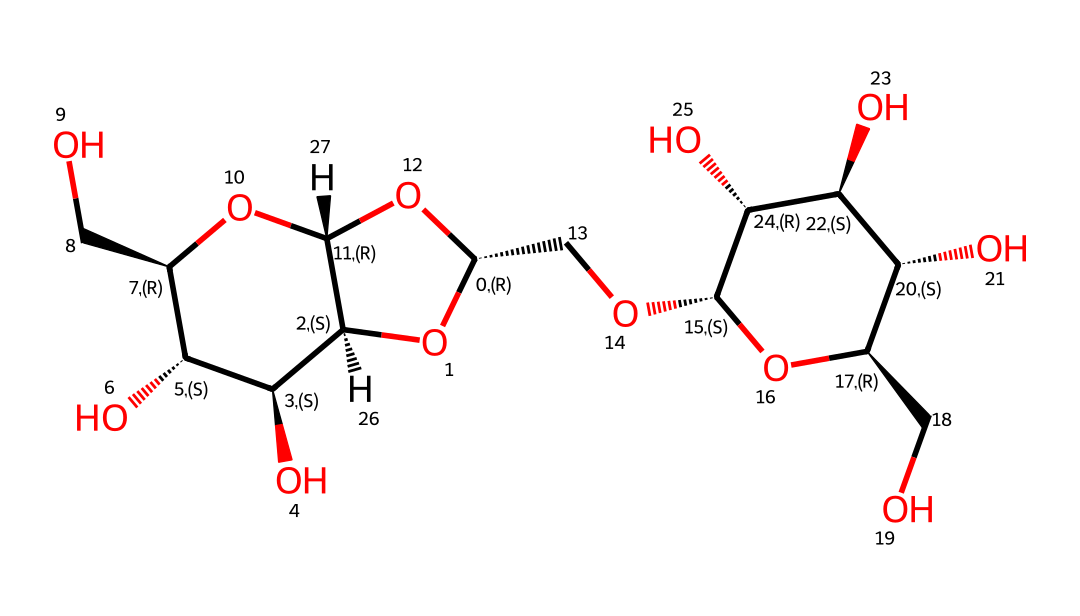What is the main type of carbohydrate represented by the structure? The chemical structure corresponds to cellulose, which is a polysaccharide formed of glucose units linked by β(1→4) glycosidic bonds. This is characteristic of cellulose, making it distinct from other types of carbohydrates.
Answer: cellulose How many carbon atoms are present in the structure? By analyzing the SMILES notation, the structure reveals a total of six carbon atoms within its unit, which is typical for the glucose monomers that compose cellulose.
Answer: six What functional groups are present in the structure? The structure contains hydroxyl (–OH) groups, which are inherent to carbohydrates like cellulose and contribute to its solubility and reactivity.
Answer: hydroxyl groups What is the degree of polymerization for cellulose depicted here? Considering that cellulose consists of repeating units of glucose, each connected through glycosidic bonds, the degree of polymerization can be inferred from the total number of monomeric units visible, which is often significant in cellulose. In this case, the structure suggests a degree greater than ten.
Answer: greater than ten What type of glycosidic linkage is found in this structure? The linkage in the structure is a β(1→4) glycosidic bond, a key feature that contributes to the stability and rigidity of cellulose, distinguishing it from other polysaccharides like starch, which has α(1→4) linkages.
Answer: β(1→4) 